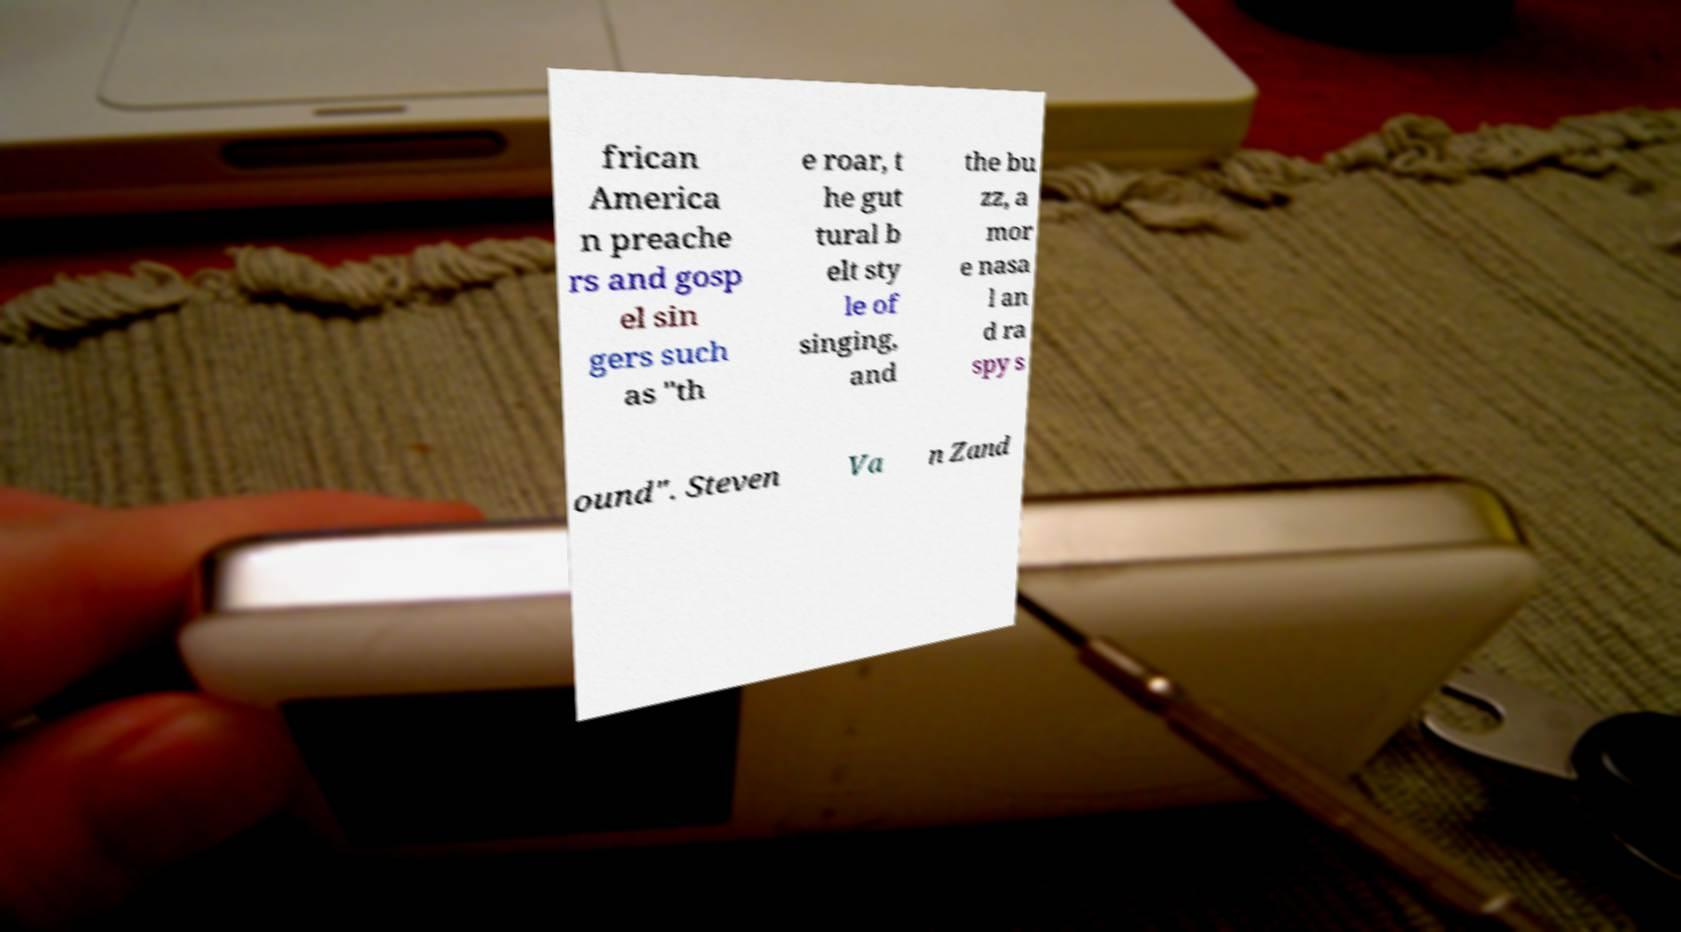There's text embedded in this image that I need extracted. Can you transcribe it verbatim? frican America n preache rs and gosp el sin gers such as "th e roar, t he gut tural b elt sty le of singing, and the bu zz, a mor e nasa l an d ra spy s ound". Steven Va n Zand 